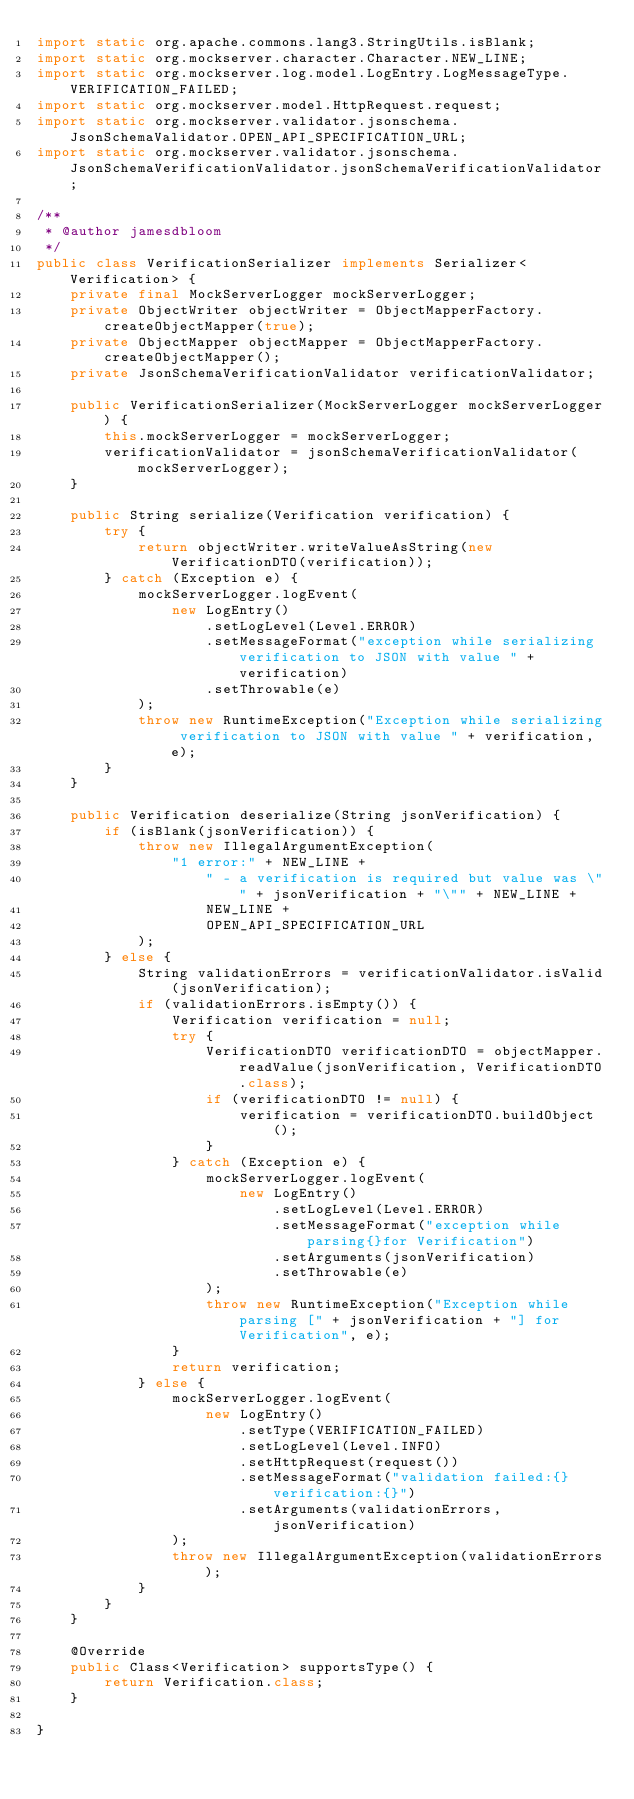<code> <loc_0><loc_0><loc_500><loc_500><_Java_>import static org.apache.commons.lang3.StringUtils.isBlank;
import static org.mockserver.character.Character.NEW_LINE;
import static org.mockserver.log.model.LogEntry.LogMessageType.VERIFICATION_FAILED;
import static org.mockserver.model.HttpRequest.request;
import static org.mockserver.validator.jsonschema.JsonSchemaValidator.OPEN_API_SPECIFICATION_URL;
import static org.mockserver.validator.jsonschema.JsonSchemaVerificationValidator.jsonSchemaVerificationValidator;

/**
 * @author jamesdbloom
 */
public class VerificationSerializer implements Serializer<Verification> {
    private final MockServerLogger mockServerLogger;
    private ObjectWriter objectWriter = ObjectMapperFactory.createObjectMapper(true);
    private ObjectMapper objectMapper = ObjectMapperFactory.createObjectMapper();
    private JsonSchemaVerificationValidator verificationValidator;

    public VerificationSerializer(MockServerLogger mockServerLogger) {
        this.mockServerLogger = mockServerLogger;
        verificationValidator = jsonSchemaVerificationValidator(mockServerLogger);
    }

    public String serialize(Verification verification) {
        try {
            return objectWriter.writeValueAsString(new VerificationDTO(verification));
        } catch (Exception e) {
            mockServerLogger.logEvent(
                new LogEntry()
                    .setLogLevel(Level.ERROR)
                    .setMessageFormat("exception while serializing verification to JSON with value " + verification)
                    .setThrowable(e)
            );
            throw new RuntimeException("Exception while serializing verification to JSON with value " + verification, e);
        }
    }

    public Verification deserialize(String jsonVerification) {
        if (isBlank(jsonVerification)) {
            throw new IllegalArgumentException(
                "1 error:" + NEW_LINE +
                    " - a verification is required but value was \"" + jsonVerification + "\"" + NEW_LINE +
                    NEW_LINE +
                    OPEN_API_SPECIFICATION_URL
            );
        } else {
            String validationErrors = verificationValidator.isValid(jsonVerification);
            if (validationErrors.isEmpty()) {
                Verification verification = null;
                try {
                    VerificationDTO verificationDTO = objectMapper.readValue(jsonVerification, VerificationDTO.class);
                    if (verificationDTO != null) {
                        verification = verificationDTO.buildObject();
                    }
                } catch (Exception e) {
                    mockServerLogger.logEvent(
                        new LogEntry()
                            .setLogLevel(Level.ERROR)
                            .setMessageFormat("exception while parsing{}for Verification")
                            .setArguments(jsonVerification)
                            .setThrowable(e)
                    );
                    throw new RuntimeException("Exception while parsing [" + jsonVerification + "] for Verification", e);
                }
                return verification;
            } else {
                mockServerLogger.logEvent(
                    new LogEntry()
                        .setType(VERIFICATION_FAILED)
                        .setLogLevel(Level.INFO)
                        .setHttpRequest(request())
                        .setMessageFormat("validation failed:{}verification:{}")
                        .setArguments(validationErrors, jsonVerification)
                );
                throw new IllegalArgumentException(validationErrors);
            }
        }
    }

    @Override
    public Class<Verification> supportsType() {
        return Verification.class;
    }

}
</code> 